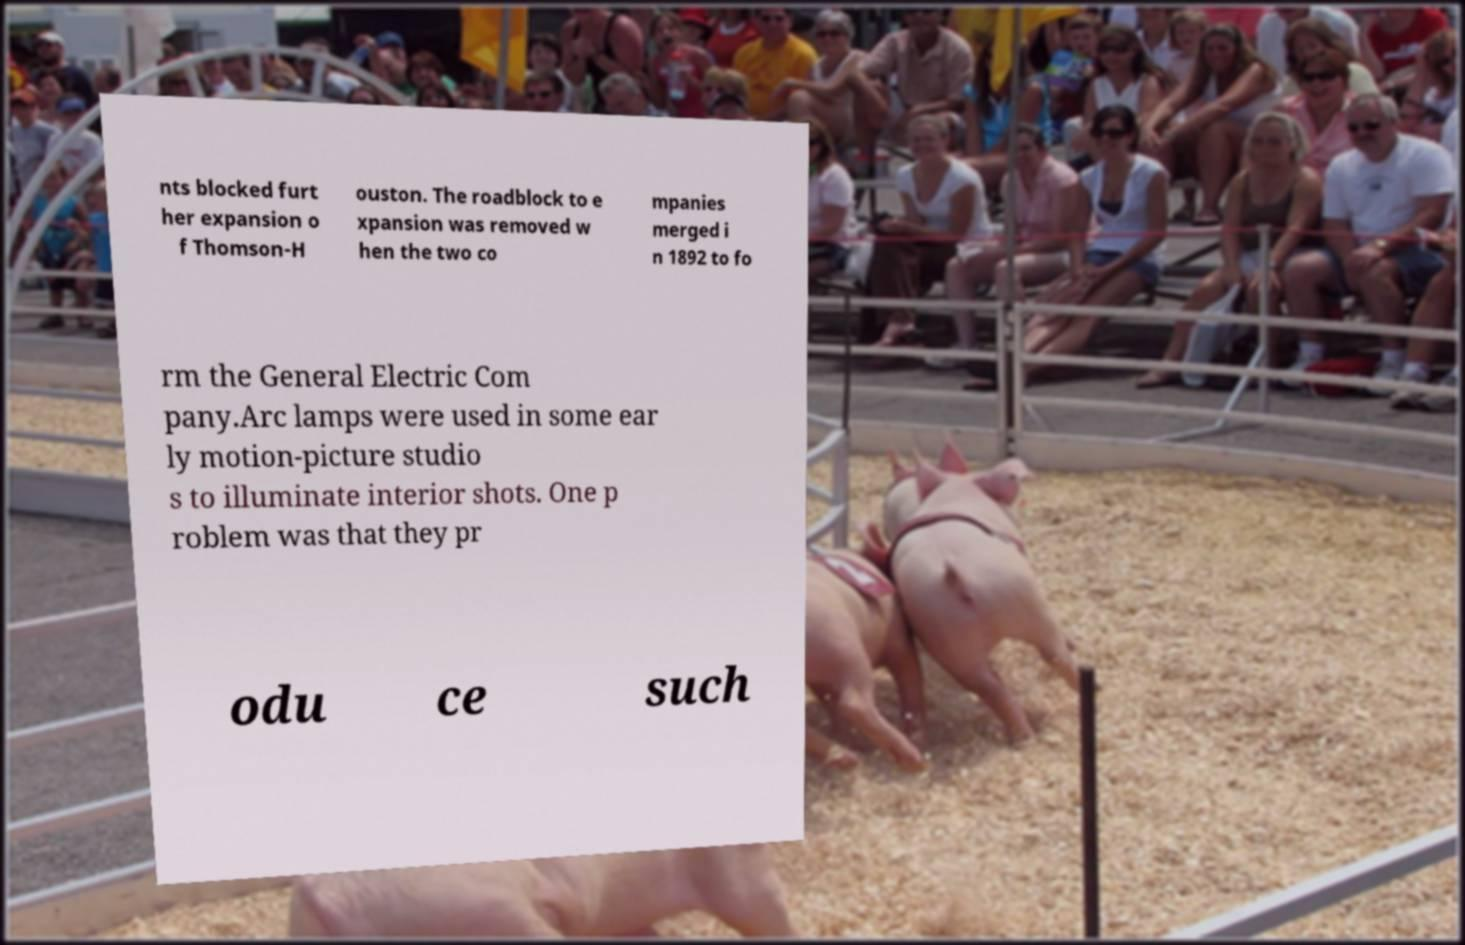Can you read and provide the text displayed in the image?This photo seems to have some interesting text. Can you extract and type it out for me? nts blocked furt her expansion o f Thomson-H ouston. The roadblock to e xpansion was removed w hen the two co mpanies merged i n 1892 to fo rm the General Electric Com pany.Arc lamps were used in some ear ly motion-picture studio s to illuminate interior shots. One p roblem was that they pr odu ce such 